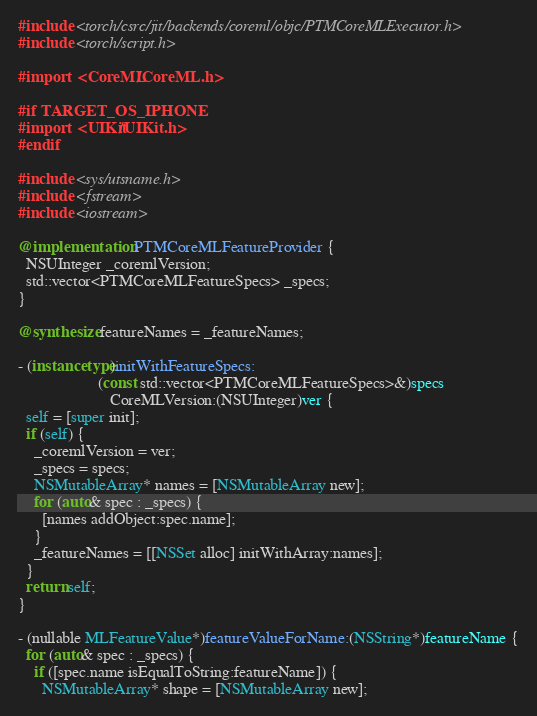<code> <loc_0><loc_0><loc_500><loc_500><_ObjectiveC_>#include <torch/csrc/jit/backends/coreml/objc/PTMCoreMLExecutor.h>
#include <torch/script.h>

#import <CoreML/CoreML.h>

#if TARGET_OS_IPHONE
#import <UIKit/UIKit.h>
#endif

#include <sys/utsname.h>
#include <fstream>
#include <iostream>

@implementation PTMCoreMLFeatureProvider {
  NSUInteger _coremlVersion;
  std::vector<PTMCoreMLFeatureSpecs> _specs;
}

@synthesize featureNames = _featureNames;

- (instancetype)initWithFeatureSpecs:
                    (const std::vector<PTMCoreMLFeatureSpecs>&)specs
                       CoreMLVersion:(NSUInteger)ver {
  self = [super init];
  if (self) {
    _coremlVersion = ver;
    _specs = specs;
    NSMutableArray* names = [NSMutableArray new];
    for (auto& spec : _specs) {
      [names addObject:spec.name];
    }
    _featureNames = [[NSSet alloc] initWithArray:names];
  }
  return self;
}

- (nullable MLFeatureValue*)featureValueForName:(NSString*)featureName {
  for (auto& spec : _specs) {
    if ([spec.name isEqualToString:featureName]) {
      NSMutableArray* shape = [NSMutableArray new];</code> 